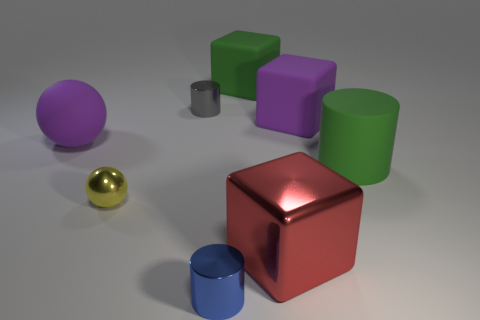Can you describe the materials of the objects? Certainly! From the lighting and reflections, we can infer the materials. The big red cube and the small golden sphere appear to have metallic finishes due to their reflective surfaces. The green cylinders and the purple and grey cubes seem to be made of rubber or a matte plastic, as they have a dull finish. The blue cylinder and the small silver cylinder have a less shiny metallic finish, and the remaining purple sphere looks matte, similar to the rubber-like objects. 